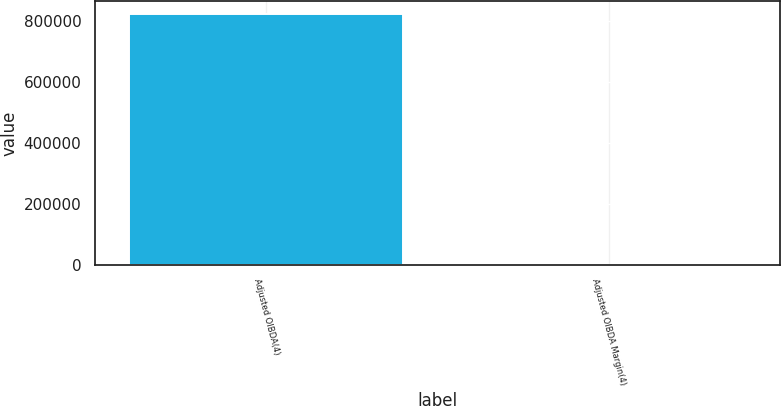Convert chart to OTSL. <chart><loc_0><loc_0><loc_500><loc_500><bar_chart><fcel>Adjusted OIBDA(4)<fcel>Adjusted OIBDA Margin(4)<nl><fcel>822579<fcel>29.6<nl></chart> 